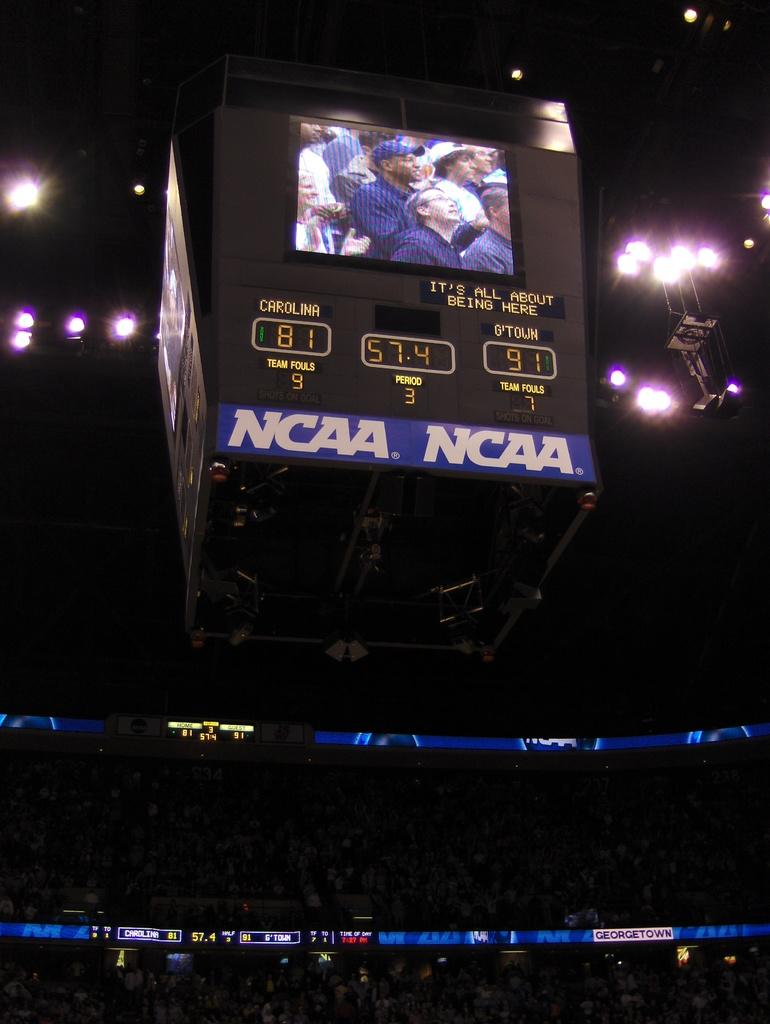<image>
Offer a succinct explanation of the picture presented. Sports game at the NCAA with a monitor at the top of a stadium showing the players and coaches and score. 